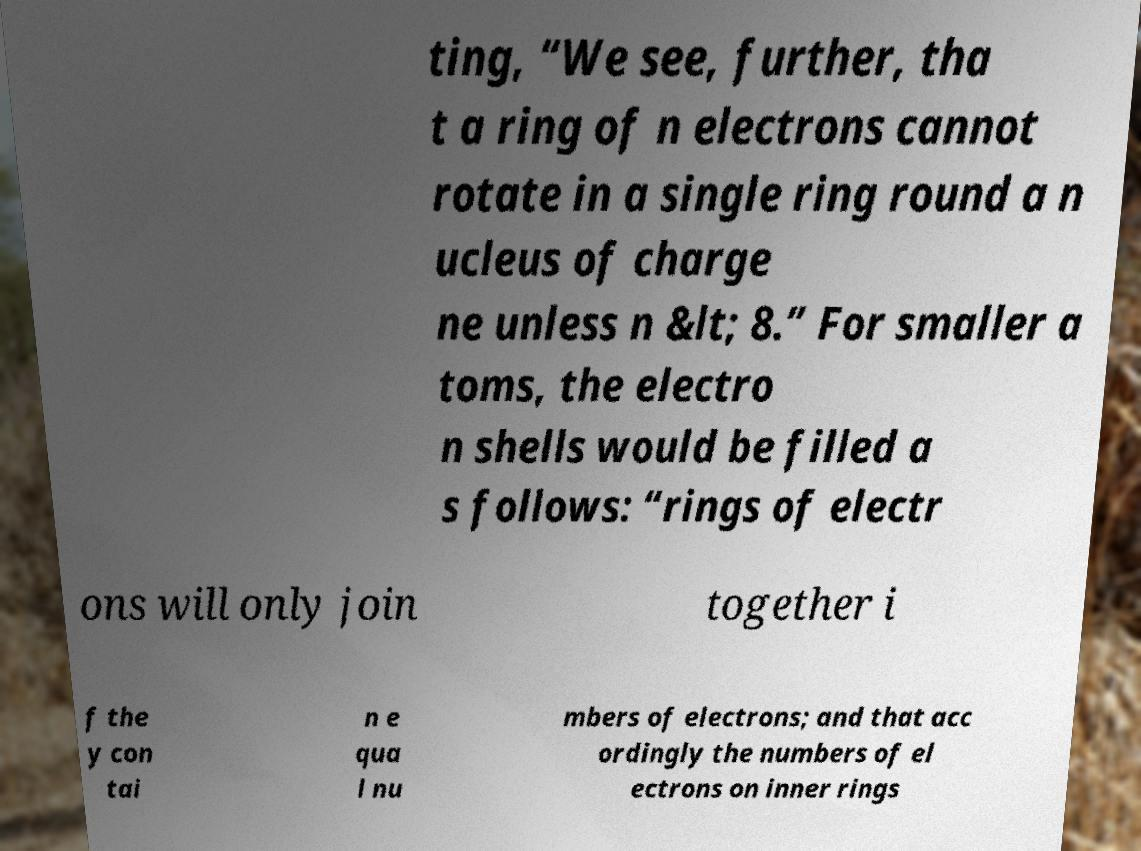Can you read and provide the text displayed in the image?This photo seems to have some interesting text. Can you extract and type it out for me? ting, “We see, further, tha t a ring of n electrons cannot rotate in a single ring round a n ucleus of charge ne unless n &lt; 8.” For smaller a toms, the electro n shells would be filled a s follows: “rings of electr ons will only join together i f the y con tai n e qua l nu mbers of electrons; and that acc ordingly the numbers of el ectrons on inner rings 